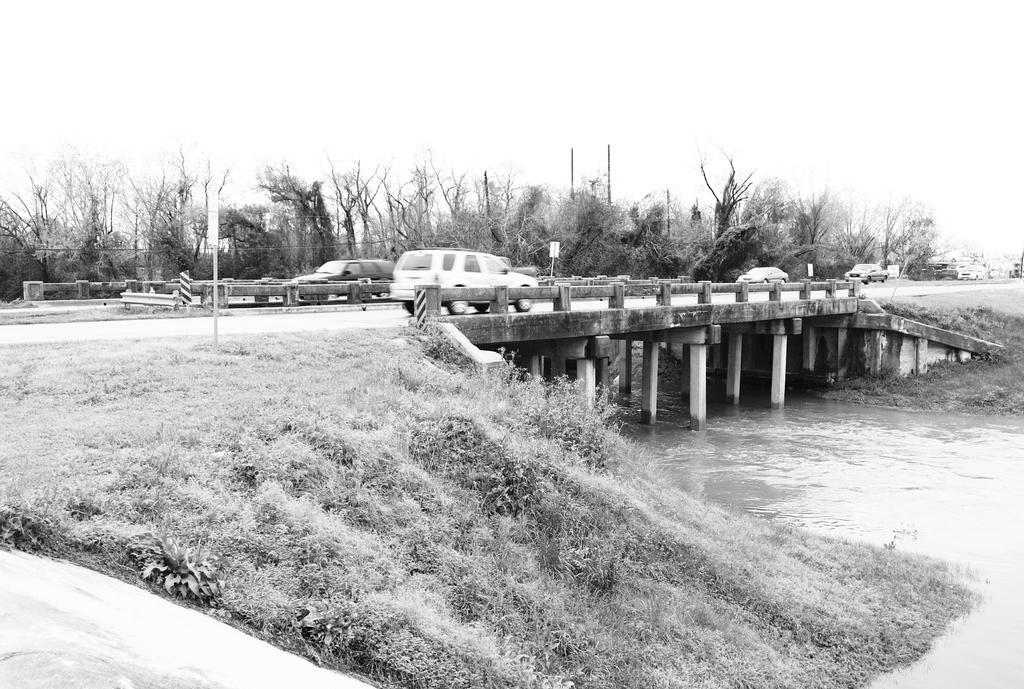Describe this image in one or two sentences. In this image we can see vehicles on the rail bridge, beside that we can see tiny poles, on the right we can see water, beside that we can see grass and plants. And we can see dried trees, at the top we can see the sky. 